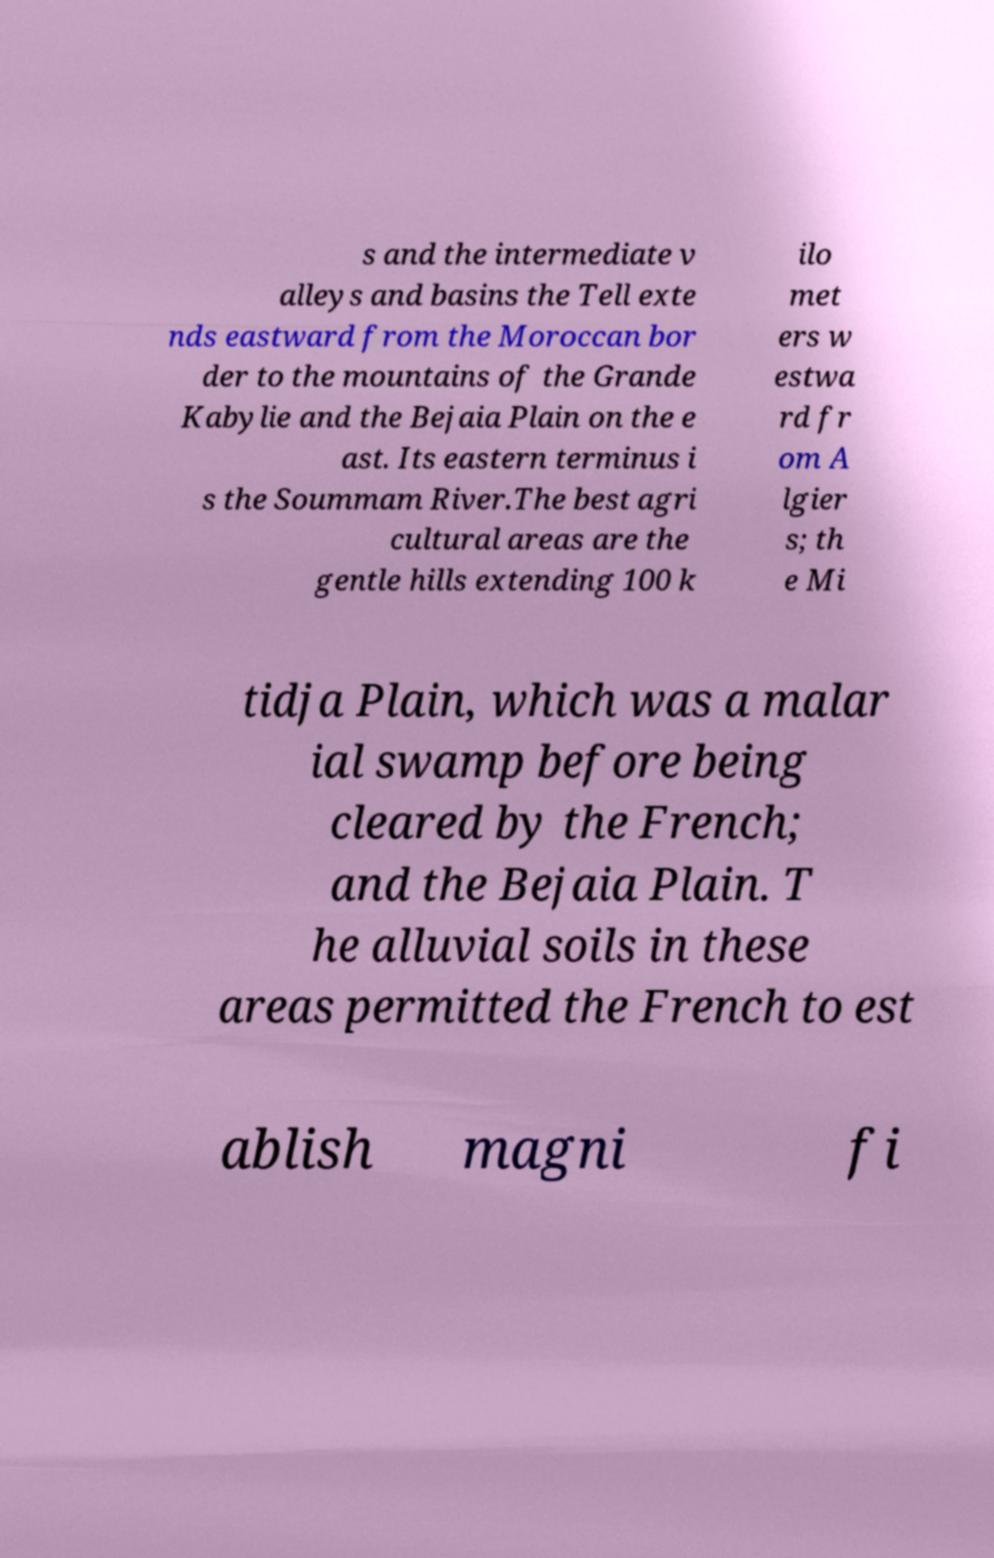There's text embedded in this image that I need extracted. Can you transcribe it verbatim? s and the intermediate v alleys and basins the Tell exte nds eastward from the Moroccan bor der to the mountains of the Grande Kabylie and the Bejaia Plain on the e ast. Its eastern terminus i s the Soummam River.The best agri cultural areas are the gentle hills extending 100 k ilo met ers w estwa rd fr om A lgier s; th e Mi tidja Plain, which was a malar ial swamp before being cleared by the French; and the Bejaia Plain. T he alluvial soils in these areas permitted the French to est ablish magni fi 